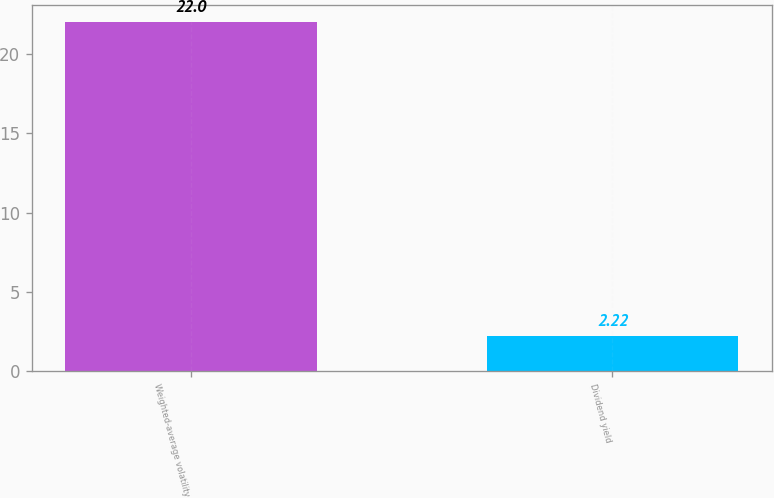Convert chart to OTSL. <chart><loc_0><loc_0><loc_500><loc_500><bar_chart><fcel>Weighted-average volatility<fcel>Dividend yield<nl><fcel>22<fcel>2.22<nl></chart> 